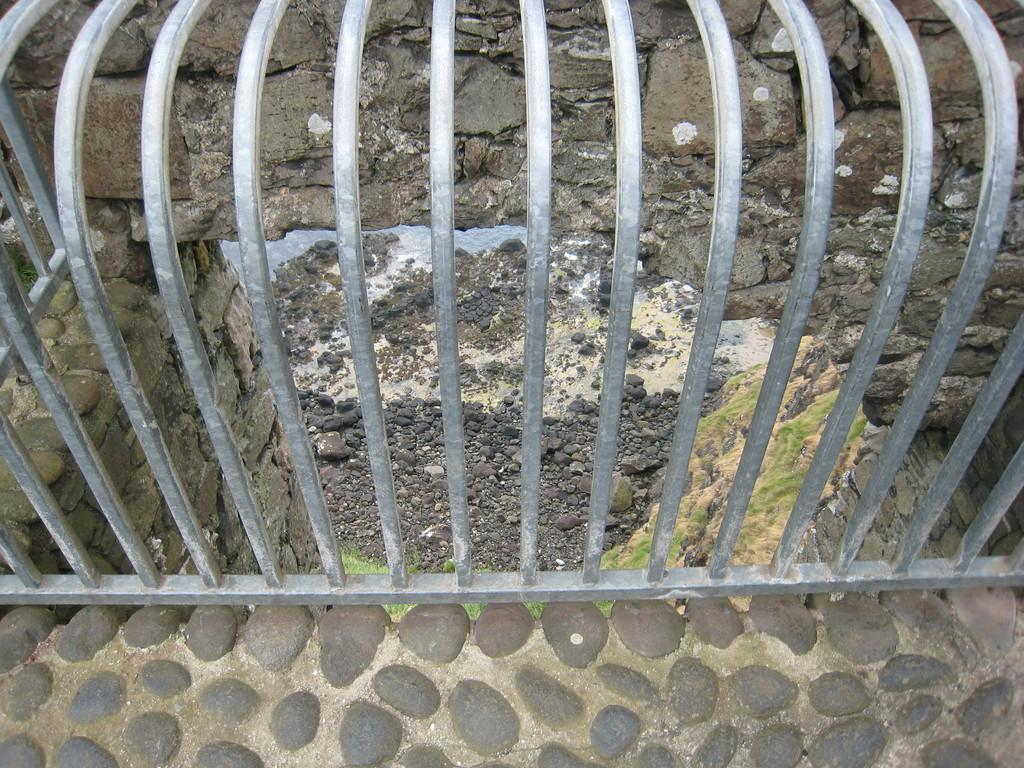What can be seen in the image that serves as a barrier or boundary? There is a railing in the image that serves as a barrier or boundary. What is located behind the railing in the image? There is a rock wall behind the railing in the image. What type of natural material covers the land in the image? There are stones on the land in the image. What type of material is used for the floor at the bottom of the image? The floor at the bottom of the image is made of pebbles. How does the honey flow through the rock wall in the image? There is no honey present in the image, so it cannot flow through the rock wall. What type of nerve is visible in the image? There are no nerves visible in the image; it features a railing, a rock wall, stones, and a pebble floor. 